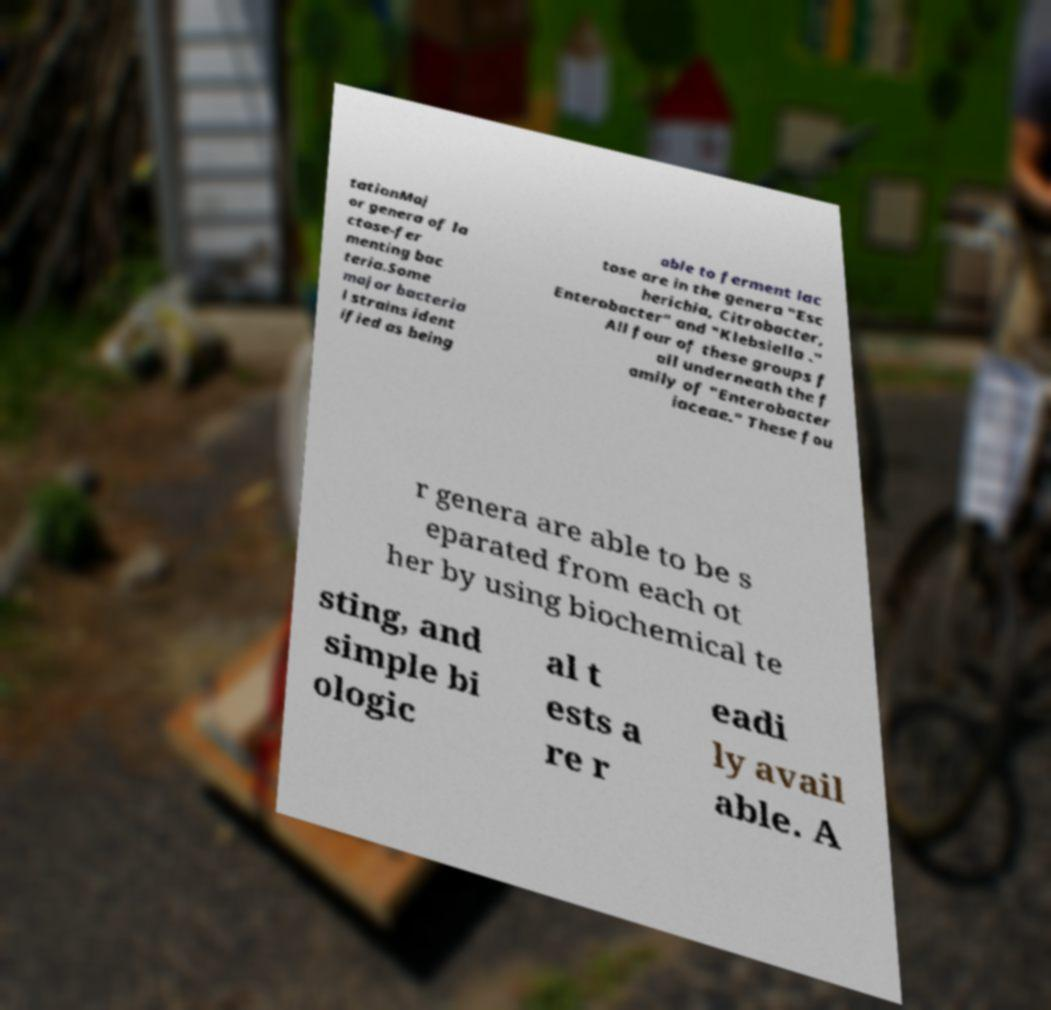Please read and relay the text visible in this image. What does it say? tationMaj or genera of la ctose-fer menting bac teria.Some major bacteria l strains ident ified as being able to ferment lac tose are in the genera "Esc herichia, Citrobacter, Enterobacter" and "Klebsiella ." All four of these groups f all underneath the f amily of "Enterobacter iaceae." These fou r genera are able to be s eparated from each ot her by using biochemical te sting, and simple bi ologic al t ests a re r eadi ly avail able. A 